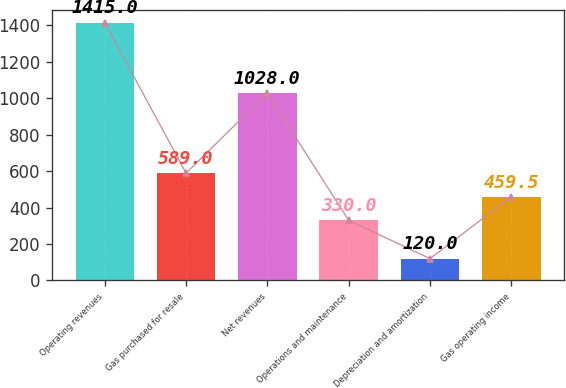Convert chart to OTSL. <chart><loc_0><loc_0><loc_500><loc_500><bar_chart><fcel>Operating revenues<fcel>Gas purchased for resale<fcel>Net revenues<fcel>Operations and maintenance<fcel>Depreciation and amortization<fcel>Gas operating income<nl><fcel>1415<fcel>589<fcel>1028<fcel>330<fcel>120<fcel>459.5<nl></chart> 